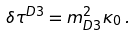Convert formula to latex. <formula><loc_0><loc_0><loc_500><loc_500>\delta \tau ^ { D 3 } = m ^ { 2 } _ { D 3 } \kappa _ { 0 } \, .</formula> 